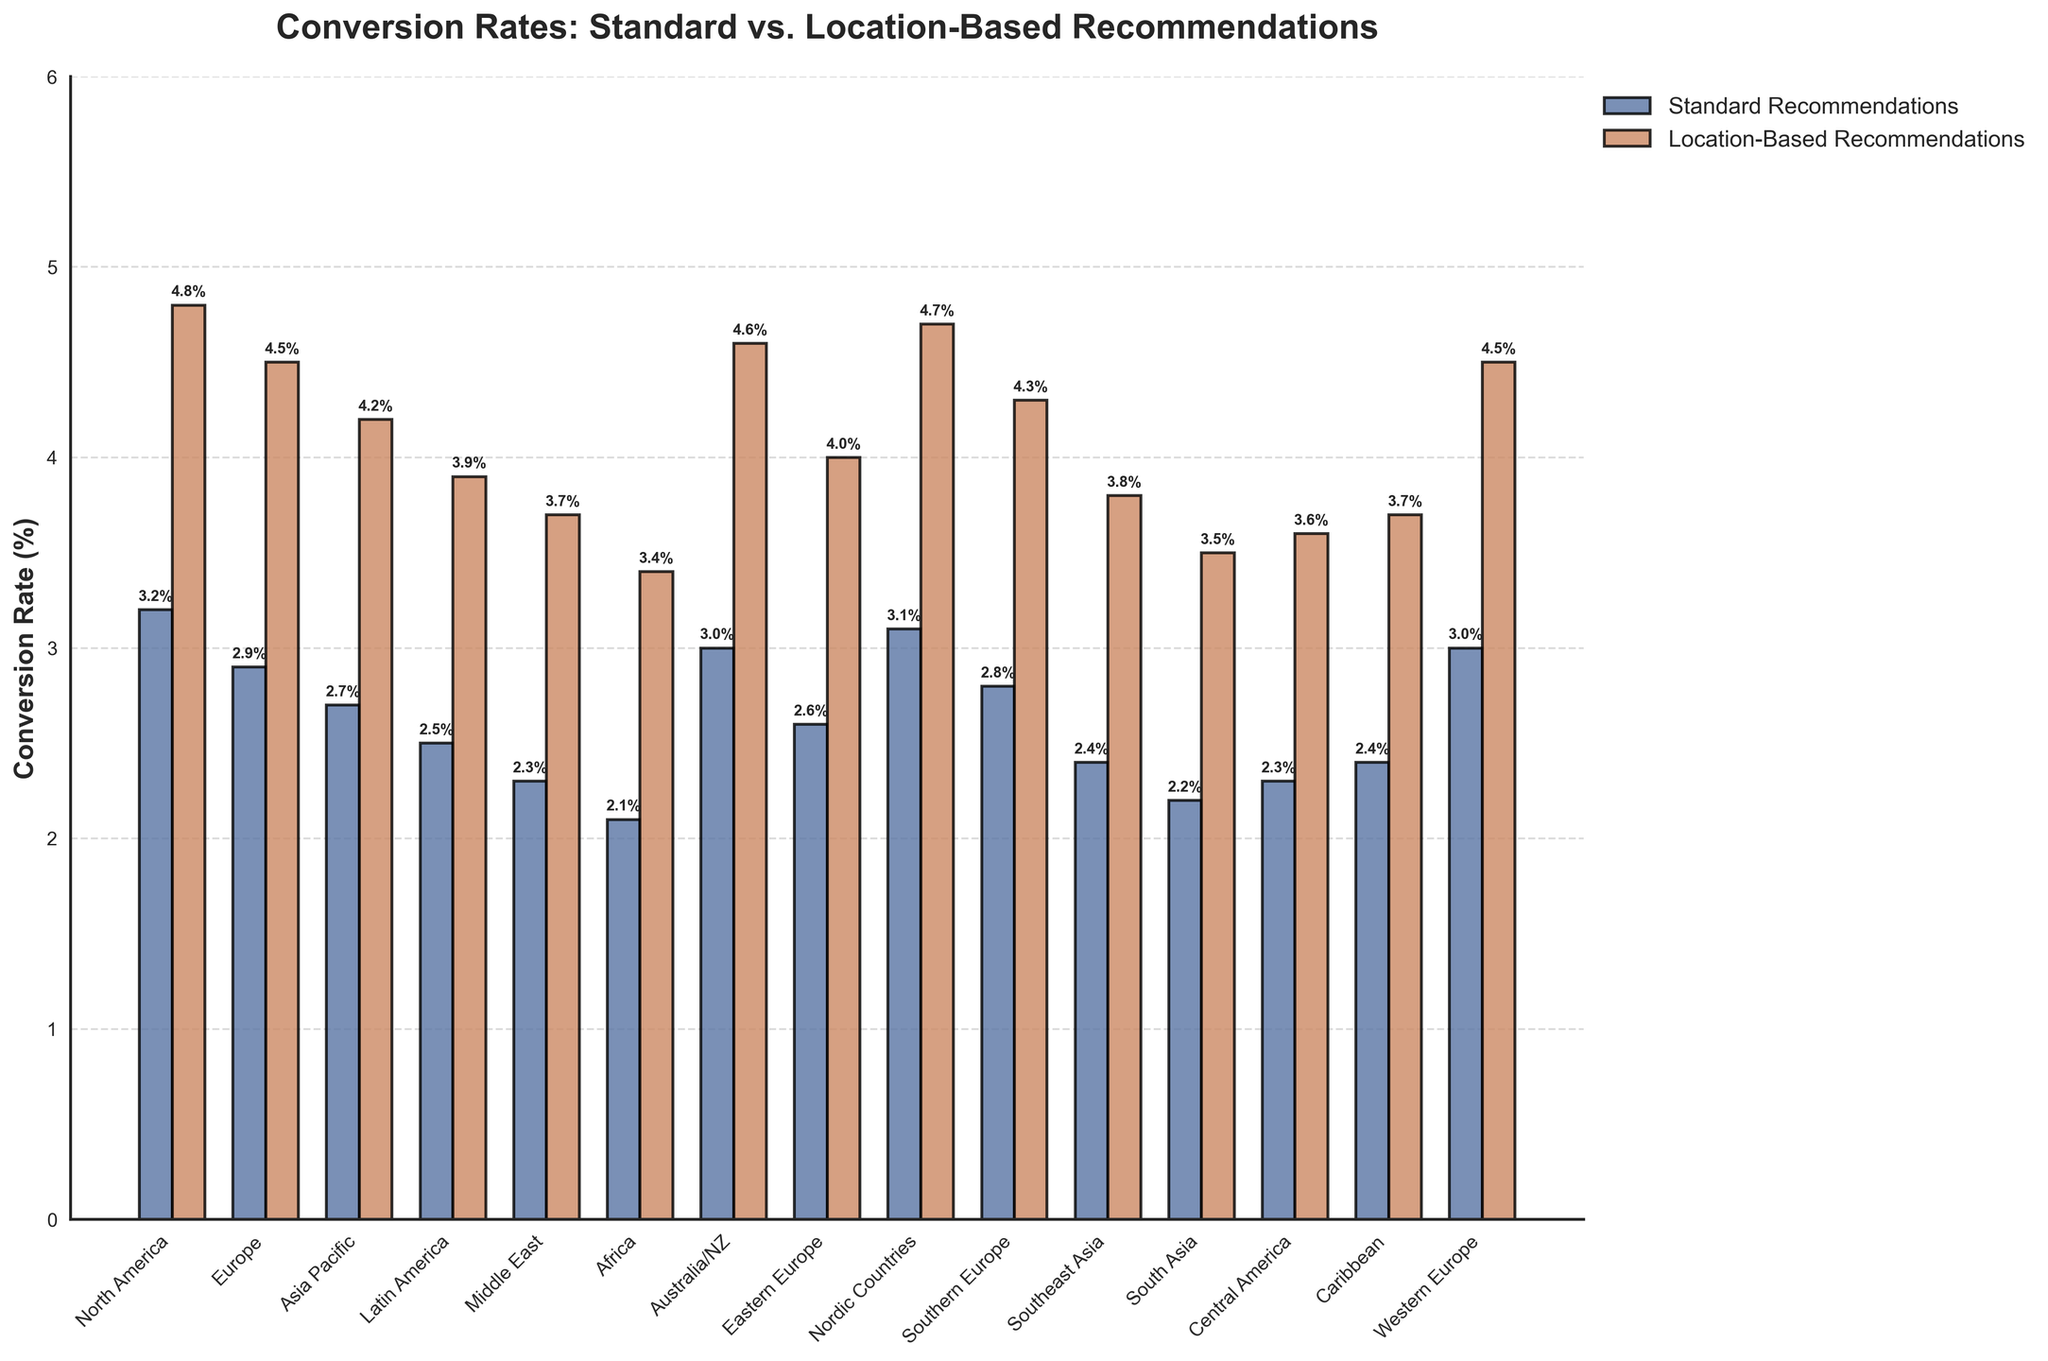Which location has the highest conversion rate for location-based recommendations? By inspecting the figure, we look for the tallest bar in the location-based recommendations group, which corresponds to North America's 4.8%.
Answer: North America What is the difference in conversion rates between standard and location-based recommendations for Europe? From the chart, the conversion rates for Europe are 2.9% for standard recommendations and 4.5% for location-based recommendations. The difference is 4.5% - 2.9% = 1.6%.
Answer: 1.6% Which location has the lowest conversion rate for standard recommendations, and what is that rate? We locate the shortest bar in the standard recommendations category, which corresponds to Africa with a conversion rate of 2.1%.
Answer: Africa, 2.1% How many locations have a standard recommendation conversion rate of 3.0% or higher? By checking each bar in the standard recommendations group, we count the locations with conversion rates of 3.0% or higher: North America, Australia/NZ, Nordic Countries, Western Europe (4 locations).
Answer: 4 What is the average conversion rate for location-based recommendations across all locations? Adding all location-based conversion rates: 4.8 + 4.5 + 4.2 + 3.9 + 3.7 + 3.4 + 4.6 + 4.0 + 4.7 + 4.3 + 3.8 + 3.5 + 3.6 + 3.7 + 4.5, and then dividing by 15, we have (61.2 / 15) = 4.08%.
Answer: 4.08% Which locations have a greater difference in conversion rates between location-based and standard recommendations than the overall average difference across all locations? First, calculate the overall average difference: (forall_locations(location_based - standard)) / number_of_locations = (1.6 + 1.6 + 1.5 + 1.4 + 1.4 + 1.3 + 1.6 + 1.4 + 1.6 + 1.5 + 1.4 + 1.3 + 1.3 + 1.3 + 1.5) / 15 = 1.45%. Locations with a greater difference: North America, Europe (1.6%), Australia/NZ, Nordic Countries (1.6%), Western Europe (1.5%).
Answer: North America, Europe, Australia/NZ, Nordic Countries Compare the conversion rates for standard and location-based recommendations in Southeast Asia, and specify how much higher one is than the other. In Southeast Asia, the conversion rates are 2.4% for standard recommendations and 3.8% for location-based recommendations. The difference is 3.8% - 2.4% = 1.4%.
Answer: 1.4% Is there any location where the conversion rate for standard recommendations is greater than 3%, and if so, which one? By examining the bars for standard recommendations, we find North America, Australia/NZ, Nordic Countries, and Western Europe have conversion rates greater than 3%.
Answer: North America, Australia/NZ, Nordic Countries, Western Europe What is the second highest conversion rate for location-based recommendations, and which location does it correspond to? We observe the bars in location-based recommendations, starting with the highest, North America at 4.8%, then the second highest is Nordic Countries at 4.7%.
Answer: Nordic Countries, 4.7% 